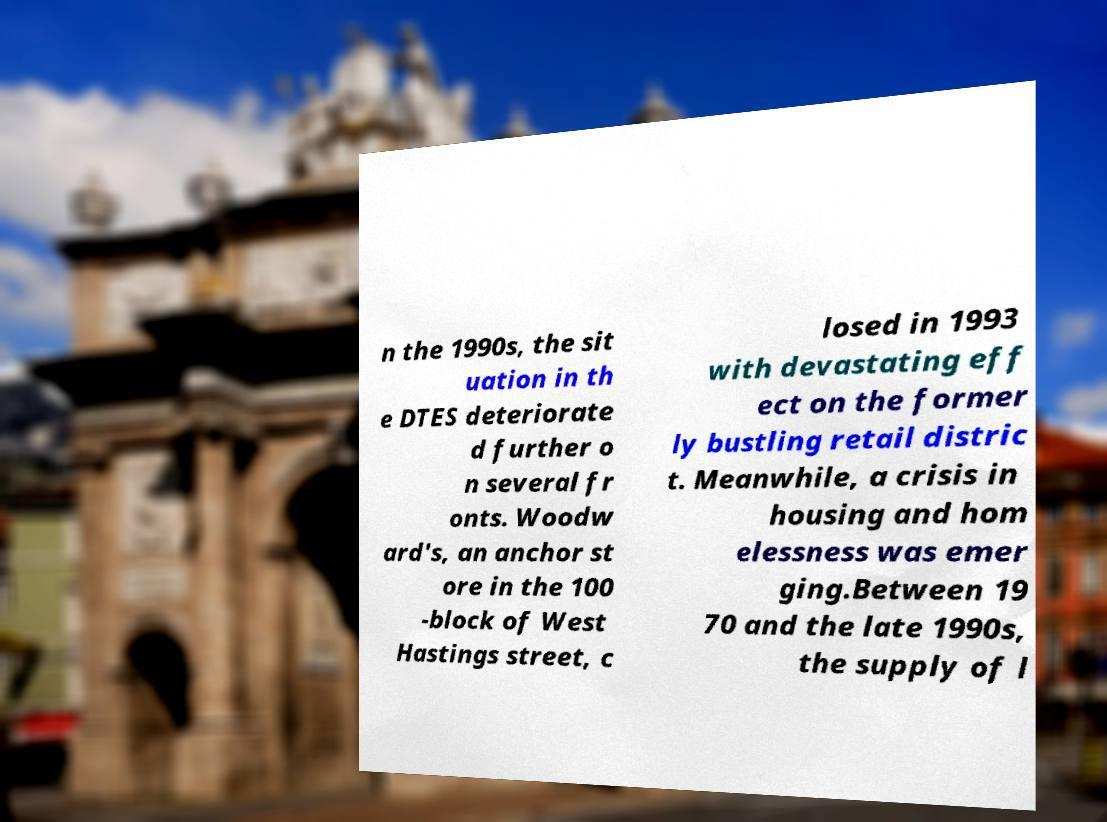Can you accurately transcribe the text from the provided image for me? n the 1990s, the sit uation in th e DTES deteriorate d further o n several fr onts. Woodw ard's, an anchor st ore in the 100 -block of West Hastings street, c losed in 1993 with devastating eff ect on the former ly bustling retail distric t. Meanwhile, a crisis in housing and hom elessness was emer ging.Between 19 70 and the late 1990s, the supply of l 